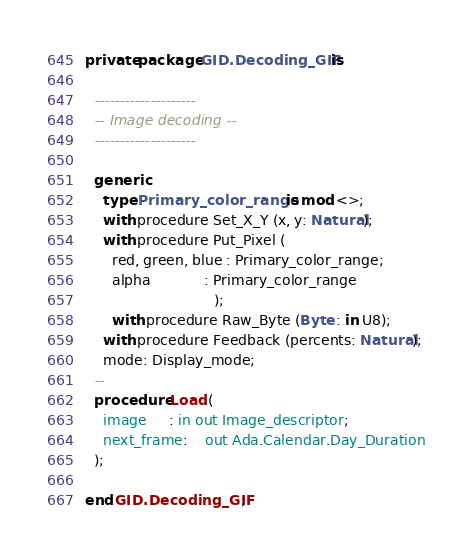<code> <loc_0><loc_0><loc_500><loc_500><_Ada_>private package GID.Decoding_GIF is

  --------------------
  -- Image decoding --
  --------------------

  generic
    type Primary_color_range is mod <>;
    with procedure Set_X_Y (x, y: Natural);
    with procedure Put_Pixel (
      red, green, blue : Primary_color_range;
      alpha            : Primary_color_range
                             );
      with procedure Raw_Byte (Byte : in U8);
    with procedure Feedback (percents: Natural);
    mode: Display_mode;
  --
  procedure Load (
    image     : in out Image_descriptor;
    next_frame:    out Ada.Calendar.Day_Duration
  );

end GID.Decoding_GIF;
</code> 